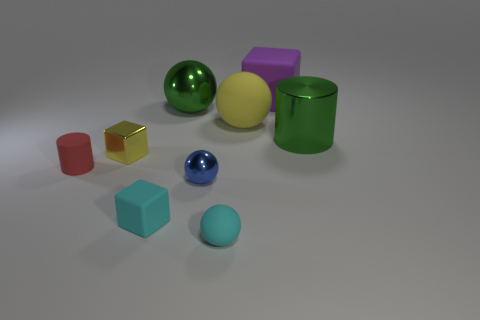Does the green cylinder have the same size as the yellow metal thing?
Provide a succinct answer. No. Is there a large shiny object of the same color as the big metal cylinder?
Provide a short and direct response. Yes. What number of blocks are big purple rubber objects or yellow matte objects?
Your answer should be very brief. 1. Is there a large cyan object that has the same shape as the large purple thing?
Provide a succinct answer. No. How many other objects are the same color as the tiny metallic ball?
Make the answer very short. 0. Is the number of tiny cyan matte cubes behind the large purple cube less than the number of matte objects?
Your answer should be very brief. Yes. What number of big blue balls are there?
Your answer should be compact. 0. What number of red objects are made of the same material as the blue object?
Your answer should be very brief. 0. How many objects are either objects that are to the right of the large block or tiny yellow shiny blocks?
Give a very brief answer. 2. Are there fewer tiny red matte objects that are right of the small yellow block than tiny objects behind the tiny cylinder?
Offer a very short reply. Yes. 